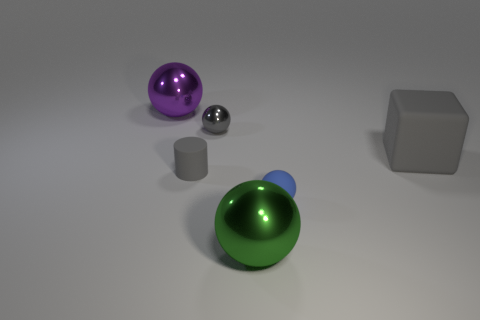How are the objects arranged? The objects are arranged on an even surface. The green shiny ball is in the foreground, closely followed by the small metal cylinder, with the purple ball positioned behind them. The metal sphere sits to the side and the cube is behind all other objects, slightly off-center. Does the positioning of the objects suggest anything about their relationship or function? Their arrangement doesn't imply a functional relationship; it seems more like a still-life display. The objects are organized to create a sense of depth, possibly for a study of light, reflection, and shadows in a three-dimensional space. 